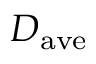Convert formula to latex. <formula><loc_0><loc_0><loc_500><loc_500>D _ { a v e }</formula> 